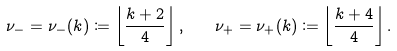<formula> <loc_0><loc_0><loc_500><loc_500>\nu _ { - } = \nu _ { - } ( k ) \coloneqq \left \lfloor \frac { k + 2 } { 4 } \right \rfloor , \quad \nu _ { + } = \nu _ { + } ( k ) \coloneqq \left \lfloor \frac { k + 4 } { 4 } \right \rfloor .</formula> 